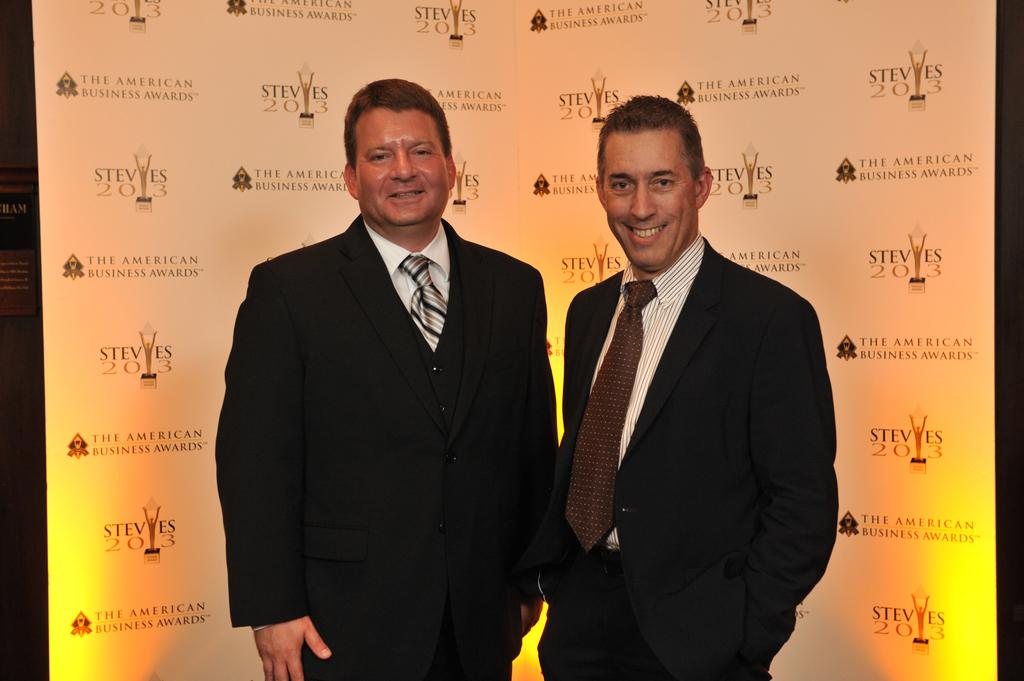What are the people in the image doing? The persons standing in the center of the image are smiling. What can be seen in the background of the image? There is a banner in the background of the image. What is written on the banner? The banner has text written on it. What is the color of the text on the banner? The text on the banner is white in color. How many bikes are parked next to the persons in the image? There are no bikes visible in the image. What type of mint is being used as a garnish on the persons' clothing? There is no mint present in the image, and the persons' clothing does not have any garnish. 